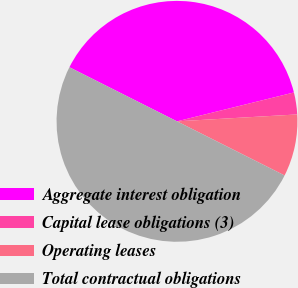Convert chart to OTSL. <chart><loc_0><loc_0><loc_500><loc_500><pie_chart><fcel>Aggregate interest obligation<fcel>Capital lease obligations (3)<fcel>Operating leases<fcel>Total contractual obligations<nl><fcel>38.73%<fcel>2.94%<fcel>8.33%<fcel>50.0%<nl></chart> 